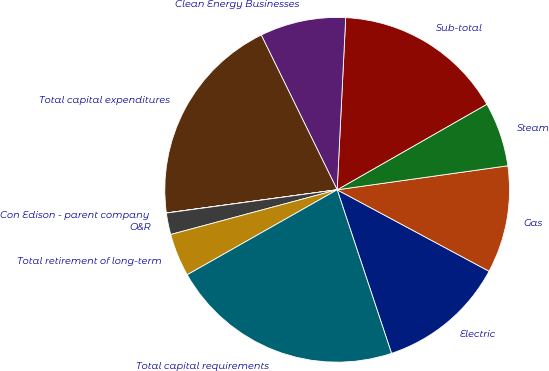Convert chart. <chart><loc_0><loc_0><loc_500><loc_500><pie_chart><fcel>Electric<fcel>Gas<fcel>Steam<fcel>Sub-total<fcel>Clean Energy Businesses<fcel>Total capital expenditures<fcel>Con Edison - parent company<fcel>O&R<fcel>Total retirement of long-term<fcel>Total capital requirements<nl><fcel>12.06%<fcel>10.06%<fcel>6.04%<fcel>15.95%<fcel>8.05%<fcel>19.89%<fcel>0.01%<fcel>2.02%<fcel>4.03%<fcel>21.9%<nl></chart> 